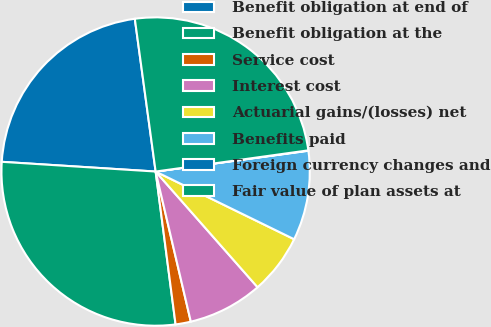<chart> <loc_0><loc_0><loc_500><loc_500><pie_chart><fcel>Benefit obligation at end of<fcel>Benefit obligation at the<fcel>Service cost<fcel>Interest cost<fcel>Actuarial gains/(losses) net<fcel>Benefits paid<fcel>Foreign currency changes and<fcel>Fair value of plan assets at<nl><fcel>21.84%<fcel>28.07%<fcel>1.6%<fcel>7.83%<fcel>6.27%<fcel>9.39%<fcel>0.04%<fcel>24.96%<nl></chart> 